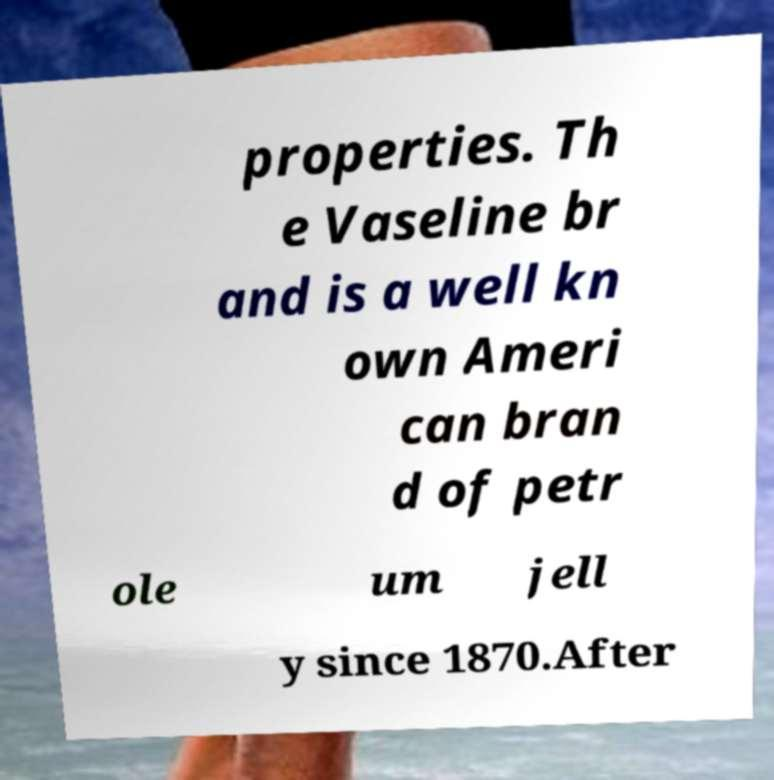Can you accurately transcribe the text from the provided image for me? properties. Th e Vaseline br and is a well kn own Ameri can bran d of petr ole um jell y since 1870.After 